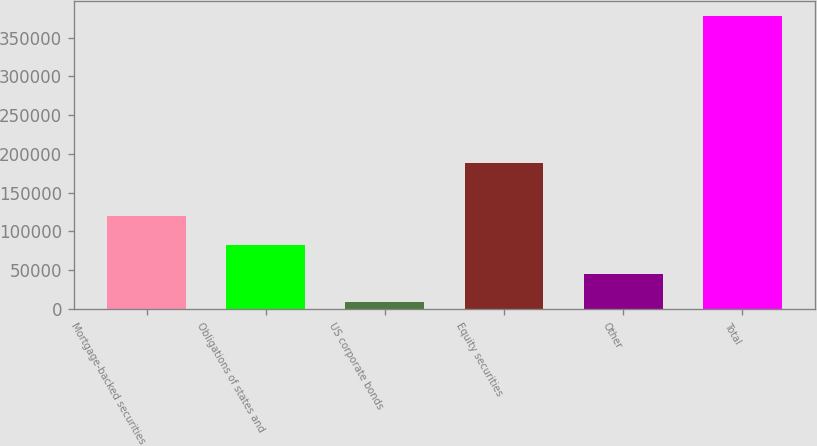Convert chart to OTSL. <chart><loc_0><loc_0><loc_500><loc_500><bar_chart><fcel>Mortgage-backed securities<fcel>Obligations of states and<fcel>US corporate bonds<fcel>Equity securities<fcel>Other<fcel>Total<nl><fcel>119344<fcel>82389<fcel>8479<fcel>188971<fcel>45434<fcel>378029<nl></chart> 